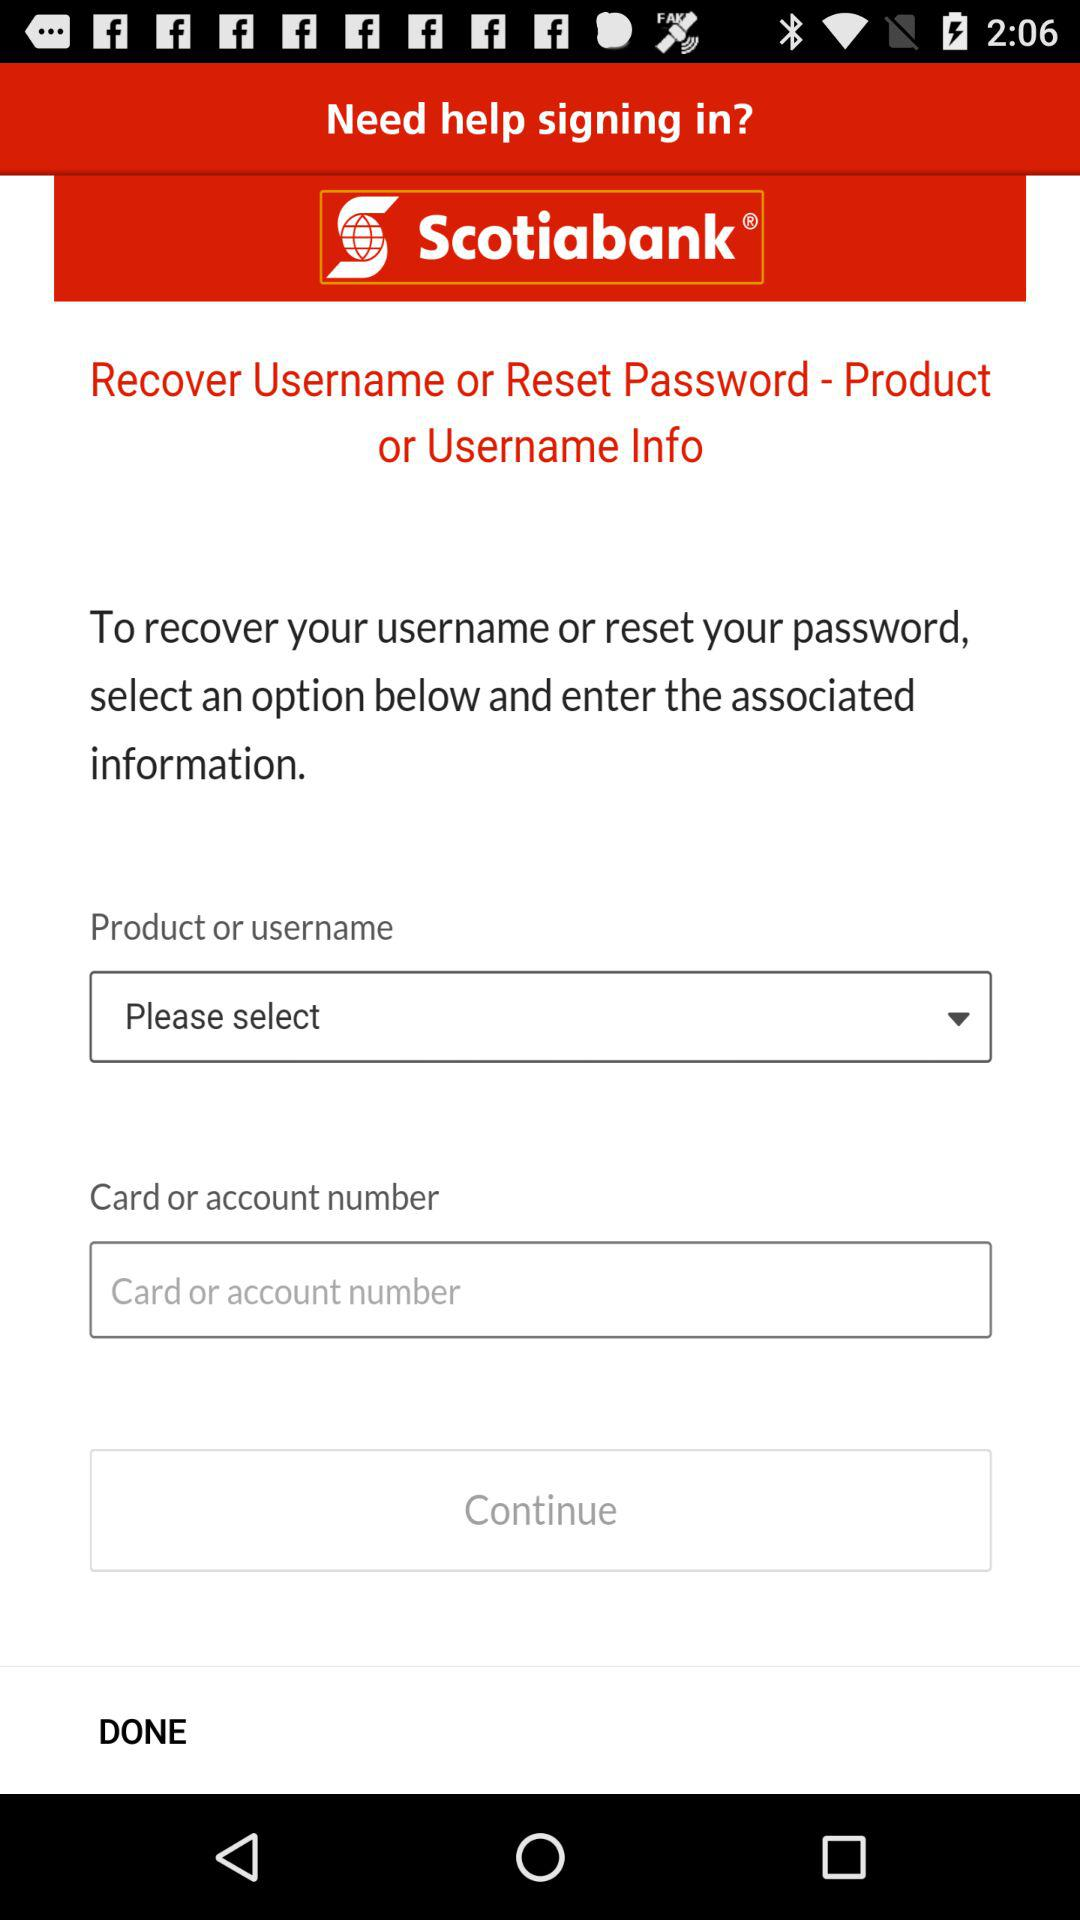Which product is selected?
When the provided information is insufficient, respond with <no answer>. <no answer> 